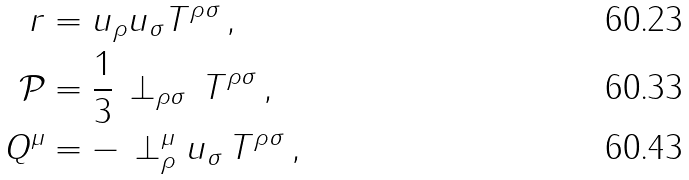<formula> <loc_0><loc_0><loc_500><loc_500>r & = u _ { \rho } u _ { \sigma } T ^ { \rho \sigma } \, , \\ \mathcal { P } & = \frac { 1 } { 3 } \, \perp _ { \rho \sigma } \, T ^ { \rho \sigma } \, , \\ Q ^ { \mu } & = - \, \perp ^ { \mu } _ { \rho } u _ { \sigma } \, T ^ { \rho \sigma } \, ,</formula> 